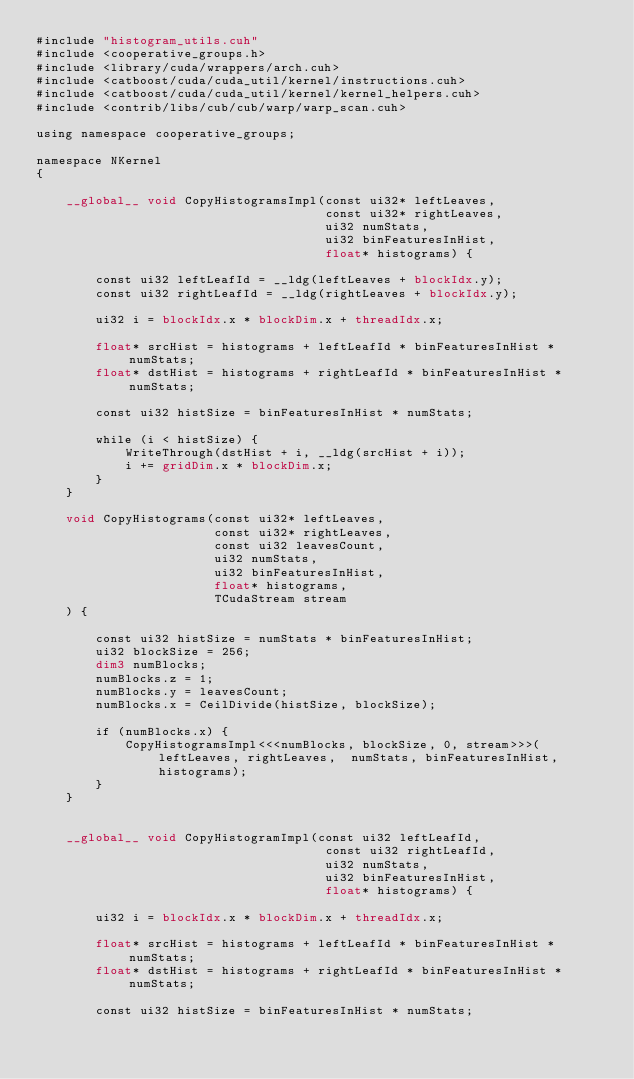<code> <loc_0><loc_0><loc_500><loc_500><_Cuda_>#include "histogram_utils.cuh"
#include <cooperative_groups.h>
#include <library/cuda/wrappers/arch.cuh>
#include <catboost/cuda/cuda_util/kernel/instructions.cuh>
#include <catboost/cuda/cuda_util/kernel/kernel_helpers.cuh>
#include <contrib/libs/cub/cub/warp/warp_scan.cuh>

using namespace cooperative_groups;

namespace NKernel
{

    __global__ void CopyHistogramsImpl(const ui32* leftLeaves,
                                       const ui32* rightLeaves,
                                       ui32 numStats,
                                       ui32 binFeaturesInHist,
                                       float* histograms) {

        const ui32 leftLeafId = __ldg(leftLeaves + blockIdx.y);
        const ui32 rightLeafId = __ldg(rightLeaves + blockIdx.y);

        ui32 i = blockIdx.x * blockDim.x + threadIdx.x;

        float* srcHist = histograms + leftLeafId * binFeaturesInHist * numStats;
        float* dstHist = histograms + rightLeafId * binFeaturesInHist * numStats;

        const ui32 histSize = binFeaturesInHist * numStats;

        while (i < histSize) {
            WriteThrough(dstHist + i, __ldg(srcHist + i));
            i += gridDim.x * blockDim.x;
        }
    }

    void CopyHistograms(const ui32* leftLeaves,
                        const ui32* rightLeaves,
                        const ui32 leavesCount,
                        ui32 numStats,
                        ui32 binFeaturesInHist,
                        float* histograms,
                        TCudaStream stream
    ) {

        const ui32 histSize = numStats * binFeaturesInHist;
        ui32 blockSize = 256;
        dim3 numBlocks;
        numBlocks.z = 1;
        numBlocks.y = leavesCount;
        numBlocks.x = CeilDivide(histSize, blockSize);

        if (numBlocks.x) {
            CopyHistogramsImpl<<<numBlocks, blockSize, 0, stream>>>(leftLeaves, rightLeaves,  numStats, binFeaturesInHist, histograms);
        }
    }


    __global__ void CopyHistogramImpl(const ui32 leftLeafId,
                                       const ui32 rightLeafId,
                                       ui32 numStats,
                                       ui32 binFeaturesInHist,
                                       float* histograms) {

        ui32 i = blockIdx.x * blockDim.x + threadIdx.x;

        float* srcHist = histograms + leftLeafId * binFeaturesInHist * numStats;
        float* dstHist = histograms + rightLeafId * binFeaturesInHist * numStats;

        const ui32 histSize = binFeaturesInHist * numStats;
</code> 